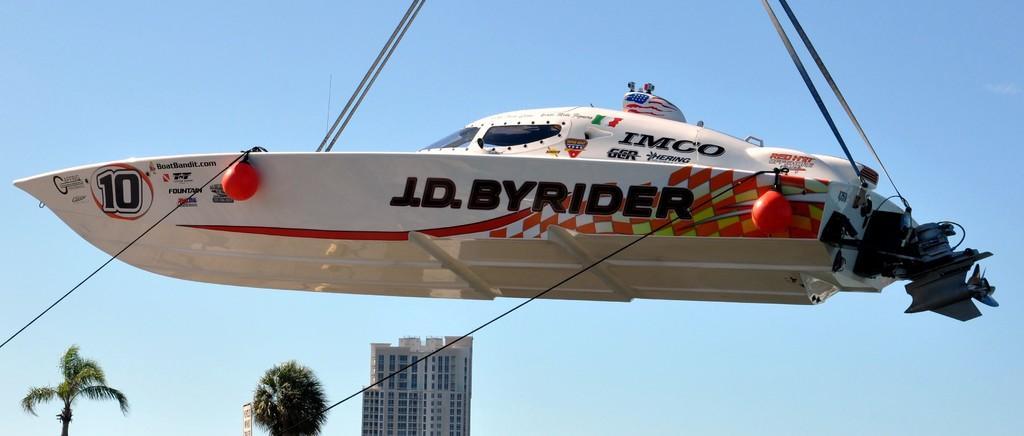Please provide a concise description of this image. In this picture we can see a boat in the water. There are a few ropes on top. We can see a rope on the left side. There are a few trees and a building in the background. 